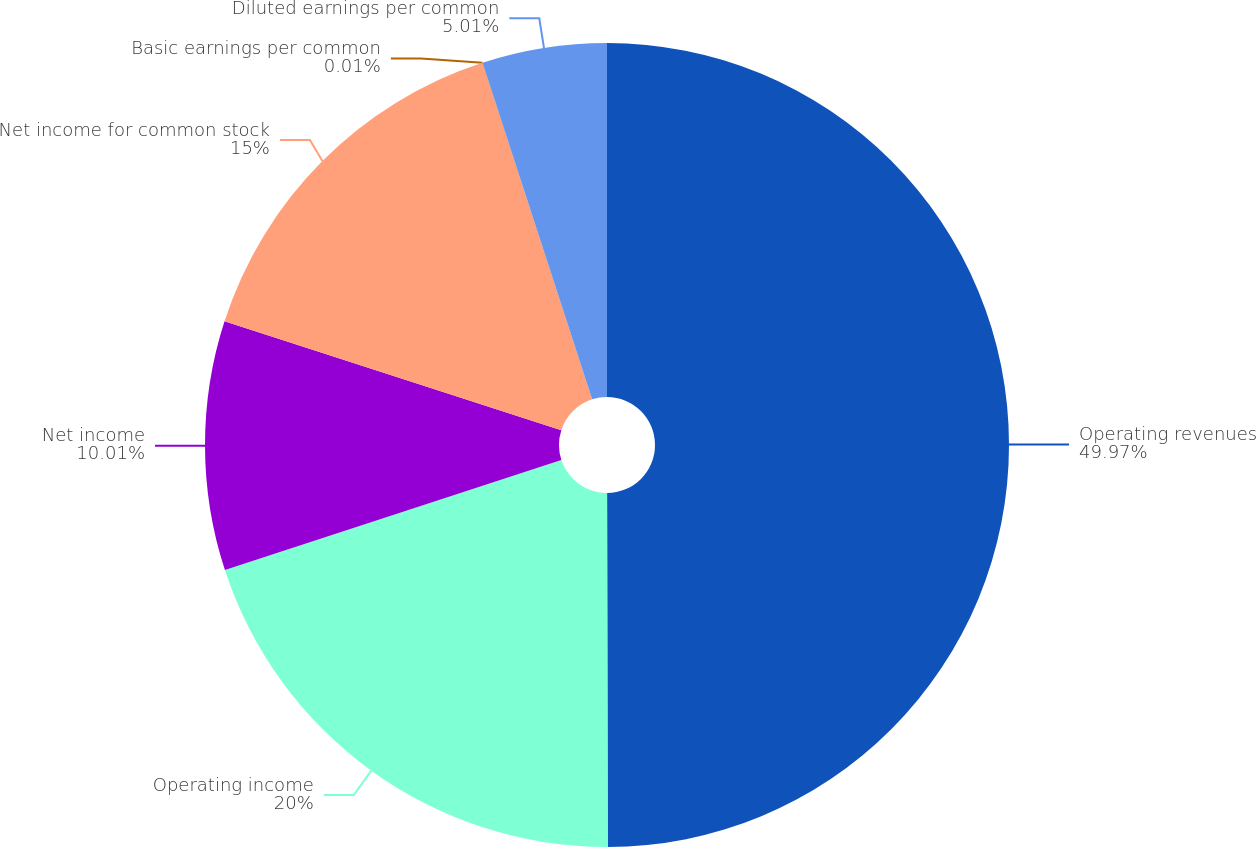Convert chart. <chart><loc_0><loc_0><loc_500><loc_500><pie_chart><fcel>Operating revenues<fcel>Operating income<fcel>Net income<fcel>Net income for common stock<fcel>Basic earnings per common<fcel>Diluted earnings per common<nl><fcel>49.97%<fcel>20.0%<fcel>10.01%<fcel>15.0%<fcel>0.01%<fcel>5.01%<nl></chart> 